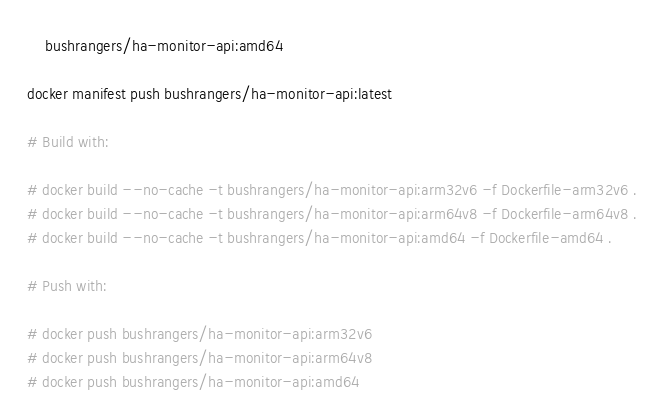Convert code to text. <code><loc_0><loc_0><loc_500><loc_500><_Bash_>    bushrangers/ha-monitor-api:amd64

docker manifest push bushrangers/ha-monitor-api:latest

# Build with:

# docker build --no-cache -t bushrangers/ha-monitor-api:arm32v6 -f Dockerfile-arm32v6 .
# docker build --no-cache -t bushrangers/ha-monitor-api:arm64v8 -f Dockerfile-arm64v8 .
# docker build --no-cache -t bushrangers/ha-monitor-api:amd64 -f Dockerfile-amd64 .

# Push with:

# docker push bushrangers/ha-monitor-api:arm32v6
# docker push bushrangers/ha-monitor-api:arm64v8
# docker push bushrangers/ha-monitor-api:amd64</code> 